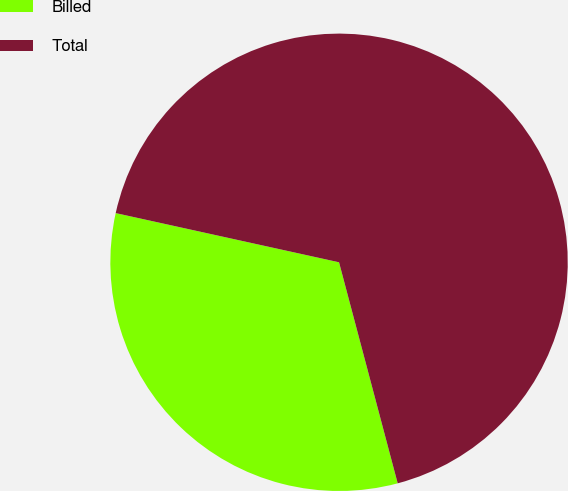<chart> <loc_0><loc_0><loc_500><loc_500><pie_chart><fcel>Billed<fcel>Total<nl><fcel>32.58%<fcel>67.42%<nl></chart> 